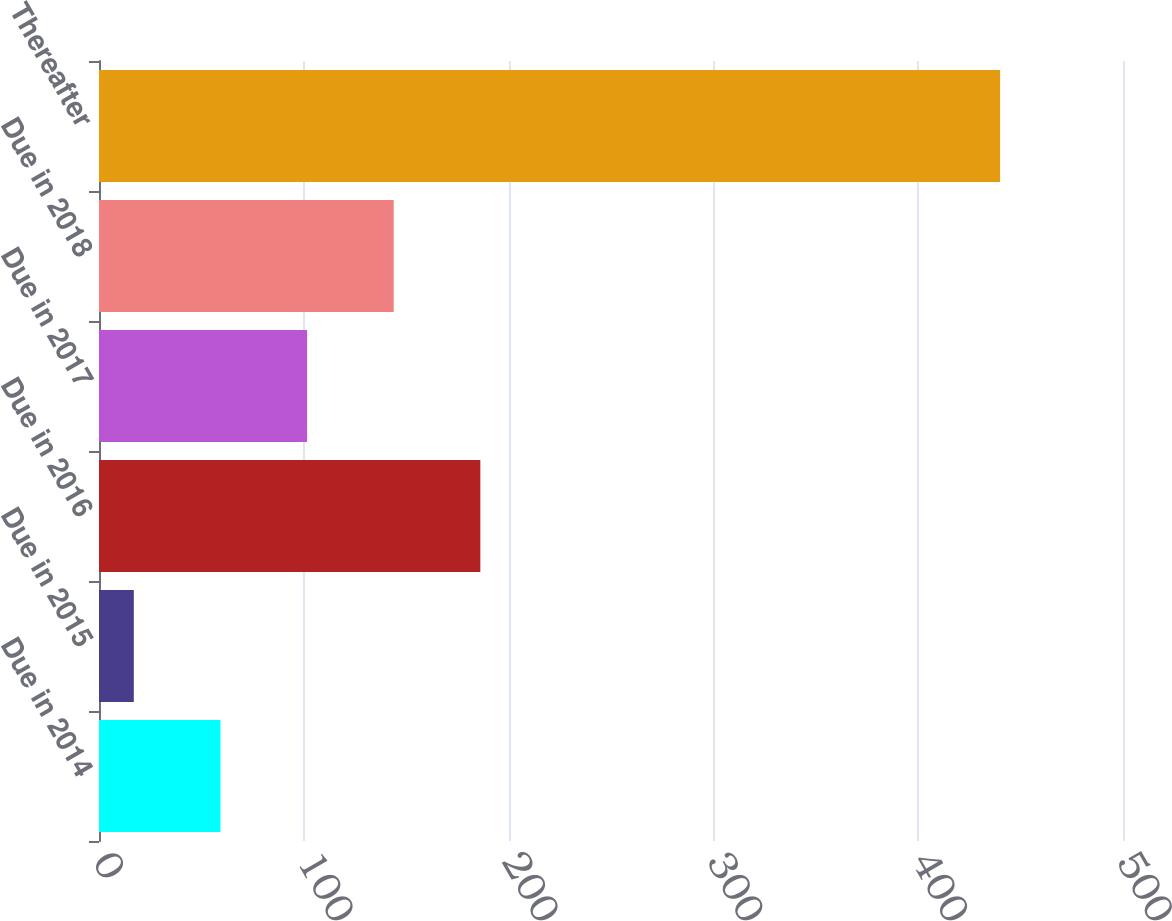<chart> <loc_0><loc_0><loc_500><loc_500><bar_chart><fcel>Due in 2014<fcel>Due in 2015<fcel>Due in 2016<fcel>Due in 2017<fcel>Due in 2018<fcel>Thereafter<nl><fcel>59.3<fcel>17<fcel>186.2<fcel>101.6<fcel>143.9<fcel>440<nl></chart> 